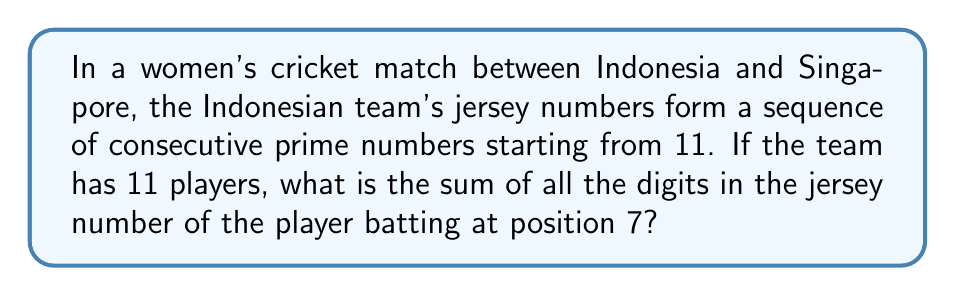Solve this math problem. Let's approach this step-by-step:

1) First, we need to identify the sequence of prime numbers starting from 11:
   11, 13, 17, 19, 23, 29, 31, 37, 41, 43, 47

2) The player batting at position 7 will have the 7th number in this sequence.
   The 7th prime number in this sequence is 31.

3) Now, we need to sum the digits of 31:
   $3 + 1 = 4$

Therefore, the sum of all the digits in the jersey number of the player batting at position 7 is 4.
Answer: 4 